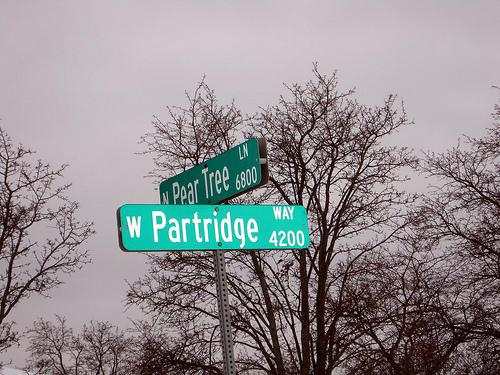Question: what color are the street signs?
Choices:
A. Green.
B. Red.
C. Orange.
D. Yellow.
Answer with the letter. Answer: A Question: how are the trees?
Choices:
A. In bloom.
B. Dead.
C. Tall.
D. Bare.
Answer with the letter. Answer: D Question: where are the trees?
Choices:
A. In front of the house.
B. On the other side of the river.
C. Far on the horizon.
D. Behind the sign.
Answer with the letter. Answer: D Question: how is the sky?
Choices:
A. Overcast.
B. Clear.
C. Cloudy.
D. Dark.
Answer with the letter. Answer: C 